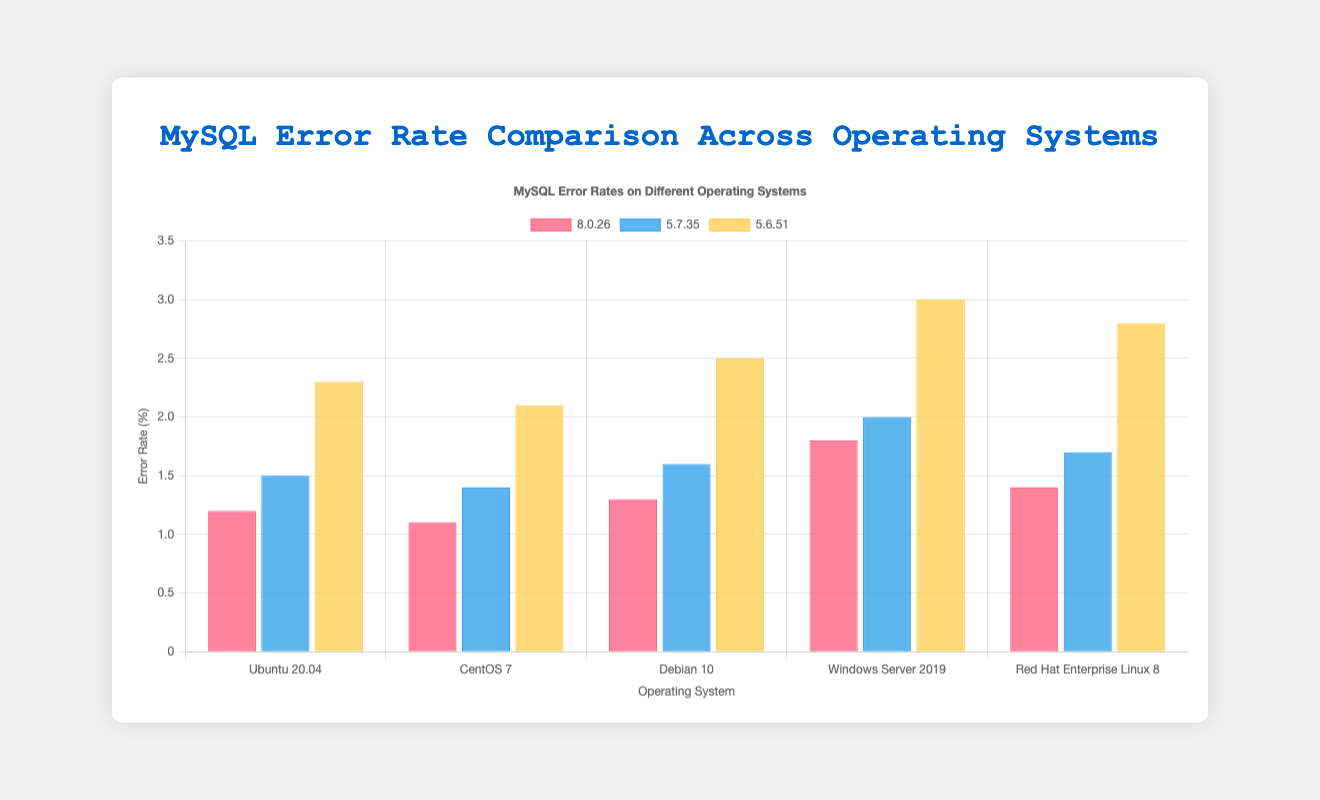What is the error rate for MySQL 5.7.35 on Ubuntu 20.04? Look for the bar representing MySQL 5.7.35 for Ubuntu 20.04, which is 1.5%
Answer: 1.5% How does the error rate of MySQL 5.6.51 on Windows Server 2019 compare to MySQL 8.0.26 on CentOS 7? Identify the error rates for MySQL 5.6.51 on Windows Server 2019 and MySQL 8.0.26 on CentOS 7, which are 3.0% and 1.1% respectively. 3.0% is higher than 1.1%
Answer: MySQL 5.6.51 on Windows Server 2019 has a higher error rate What is the average error rate of MySQL 5.6.51 across all operating systems? Sum the error rates of MySQL 5.6.51 across all OS: 2.3% + 2.1% + 2.5% + 3.0% + 2.8% = 12.7%, and then divide by the number of OS, which is 5. 12.7% / 5 = 2.54%
Answer: 2.54% Which operating system has the lowest error rate for MySQL 8.0.26? Compare the error rates for MySQL 8.0.26 across OS: Ubuntu 20.04 (1.2%), CentOS 7 (1.1%), Debian 10 (1.3%), Windows Server 2019 (1.8%), RHEL 8 (1.4%). CentOS 7 has the lowest, 1.1%
Answer: CentOS 7 What is the difference in error rate between the highest and lowest for MySQL 5.7.35? Compare the highest and lowest error rates for MySQL 5.7.35: Windows Server 2019 (2.0%) is the highest and CentOS 7 (1.4%) is the lowest. The difference is 2.0% - 1.4% = 0.6%
Answer: 0.6% Which version of MySQL has the highest error rate on Debian 10? Compare error rates for all MySQL versions on Debian 10: MySQL 8.0.26 (1.3%), MySQL 5.7.35 (1.6%), MySQL 5.6.51 (2.5%). MySQL 5.6.51 has the highest, 2.5%
Answer: MySQL 5.6.51 How many operating systems have error rates for MySQL 8.0.26 below 1.5%? Count the number of OS with MySQL 8.0.26 error rates below 1.5%: Ubuntu 20.04 (1.2%), CentOS 7 (1.1%), Debian 10 (1.3%), which is 3
Answer: 3 What's the median error rate for MySQL 8.0.26 across all operating systems? Order the error rates: 1.1%, 1.2%, 1.3%, 1.4%, 1.8%. The median value is the middle one, which is the third value (1.3%)
Answer: 1.3% For MySQL 5.6.51, which operating system has the highest error rate and what is it? Compare error rates for MySQL 5.6.51 across OS: Ubuntu 20.04 (2.3%), CentOS 7 (2.1%), Debian 10 (2.5%), Windows Server 2019 (3.0%), RHEL 8 (2.8%). Windows Server 2019 has the highest at 3.0%
Answer: Windows Server 2019, 3.0% Which operating systems have an error rate above 2% for any MySQL version? Look for operating systems with error rates above 2%: Ubuntu 20.04 (MySQL 5.6.51, 2.3%), Debian 10 (MySQL 5.6.51, 2.5%), Windows Server 2019 (MySQL 5.6.51, 3.0%; MySQL 5.7.35, 2.0%), RHEL 8 (MySQL 5.6.51, 2.8%)
Answer: Ubuntu 20.04, Debian 10, Windows Server 2019, RHEL 8 